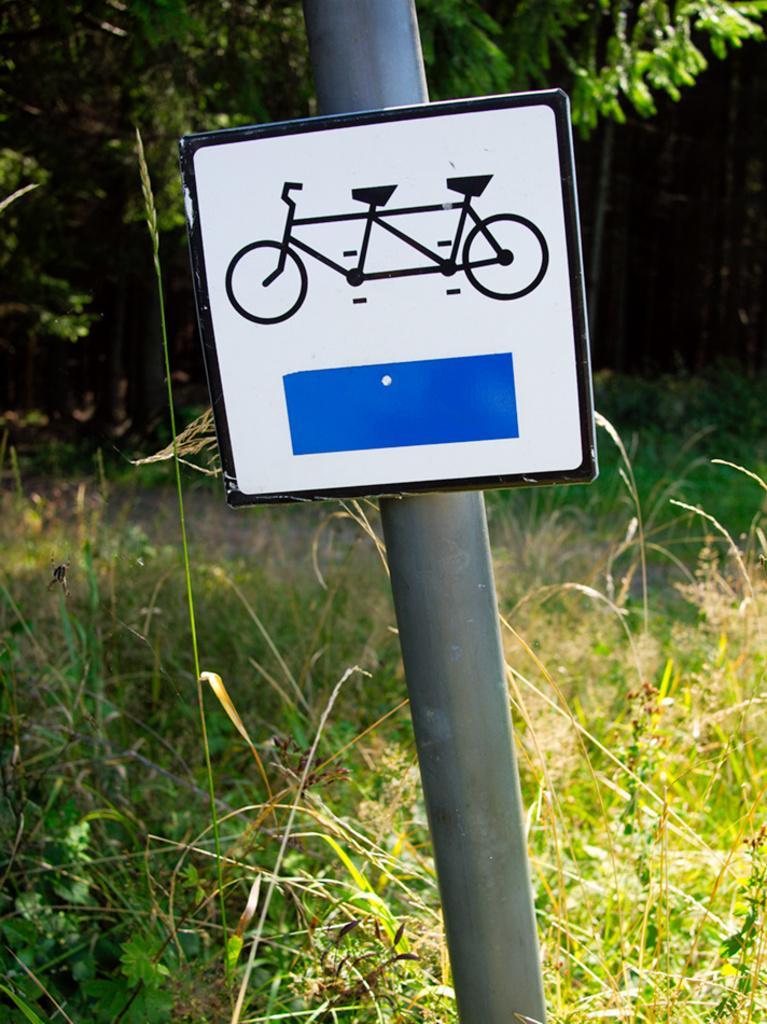Could you give a brief overview of what you see in this image? In this picture I can see a sign board to the pole and a tree and I can see grass on the ground. 